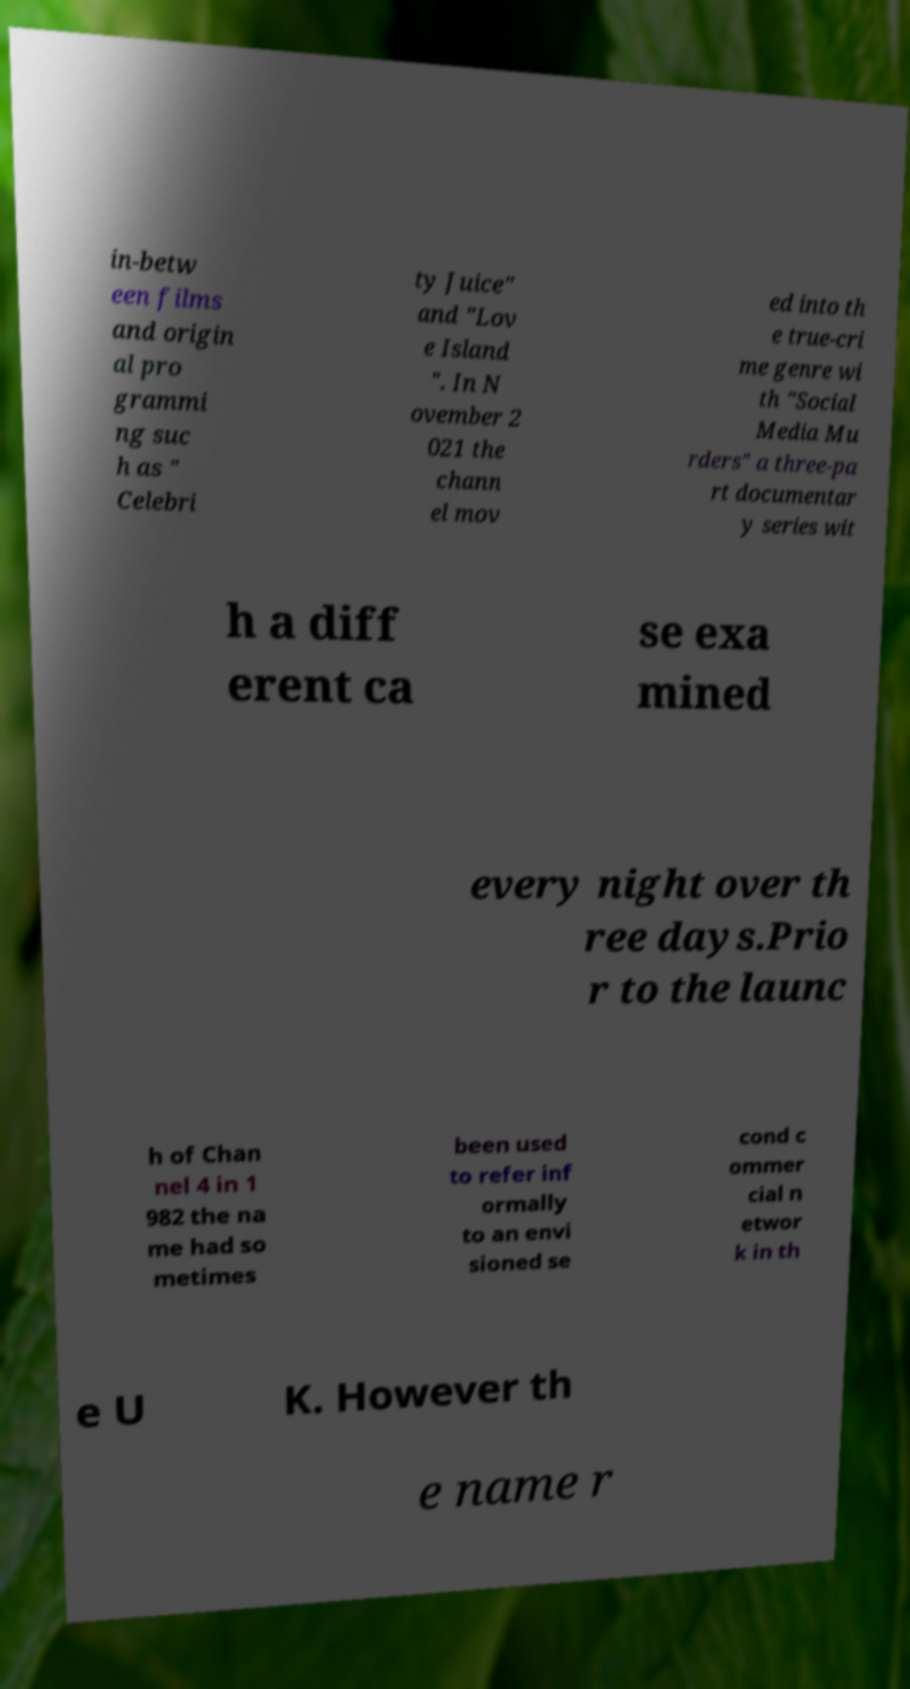Can you read and provide the text displayed in the image?This photo seems to have some interesting text. Can you extract and type it out for me? in-betw een films and origin al pro grammi ng suc h as " Celebri ty Juice" and "Lov e Island ". In N ovember 2 021 the chann el mov ed into th e true-cri me genre wi th "Social Media Mu rders" a three-pa rt documentar y series wit h a diff erent ca se exa mined every night over th ree days.Prio r to the launc h of Chan nel 4 in 1 982 the na me had so metimes been used to refer inf ormally to an envi sioned se cond c ommer cial n etwor k in th e U K. However th e name r 